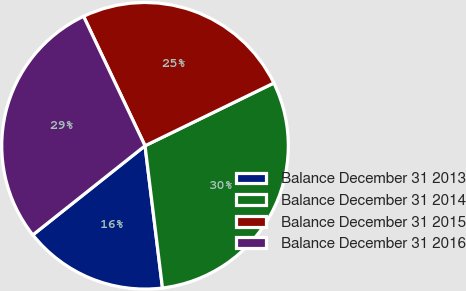Convert chart to OTSL. <chart><loc_0><loc_0><loc_500><loc_500><pie_chart><fcel>Balance December 31 2013<fcel>Balance December 31 2014<fcel>Balance December 31 2015<fcel>Balance December 31 2016<nl><fcel>16.26%<fcel>30.27%<fcel>24.84%<fcel>28.63%<nl></chart> 